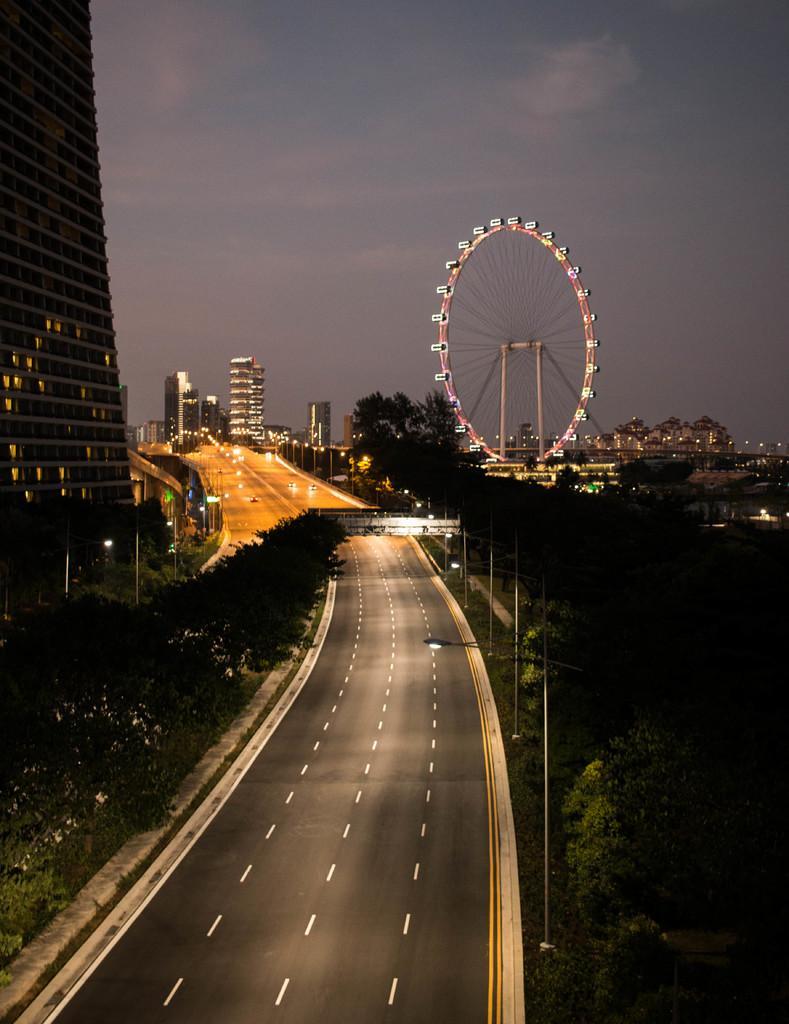How would you summarize this image in a sentence or two? In this image there is a road and we can see vehicles on the road. There are poles and trees. We can see buildings. There is a giant wheel. In the background there is sky and we can see lights. 